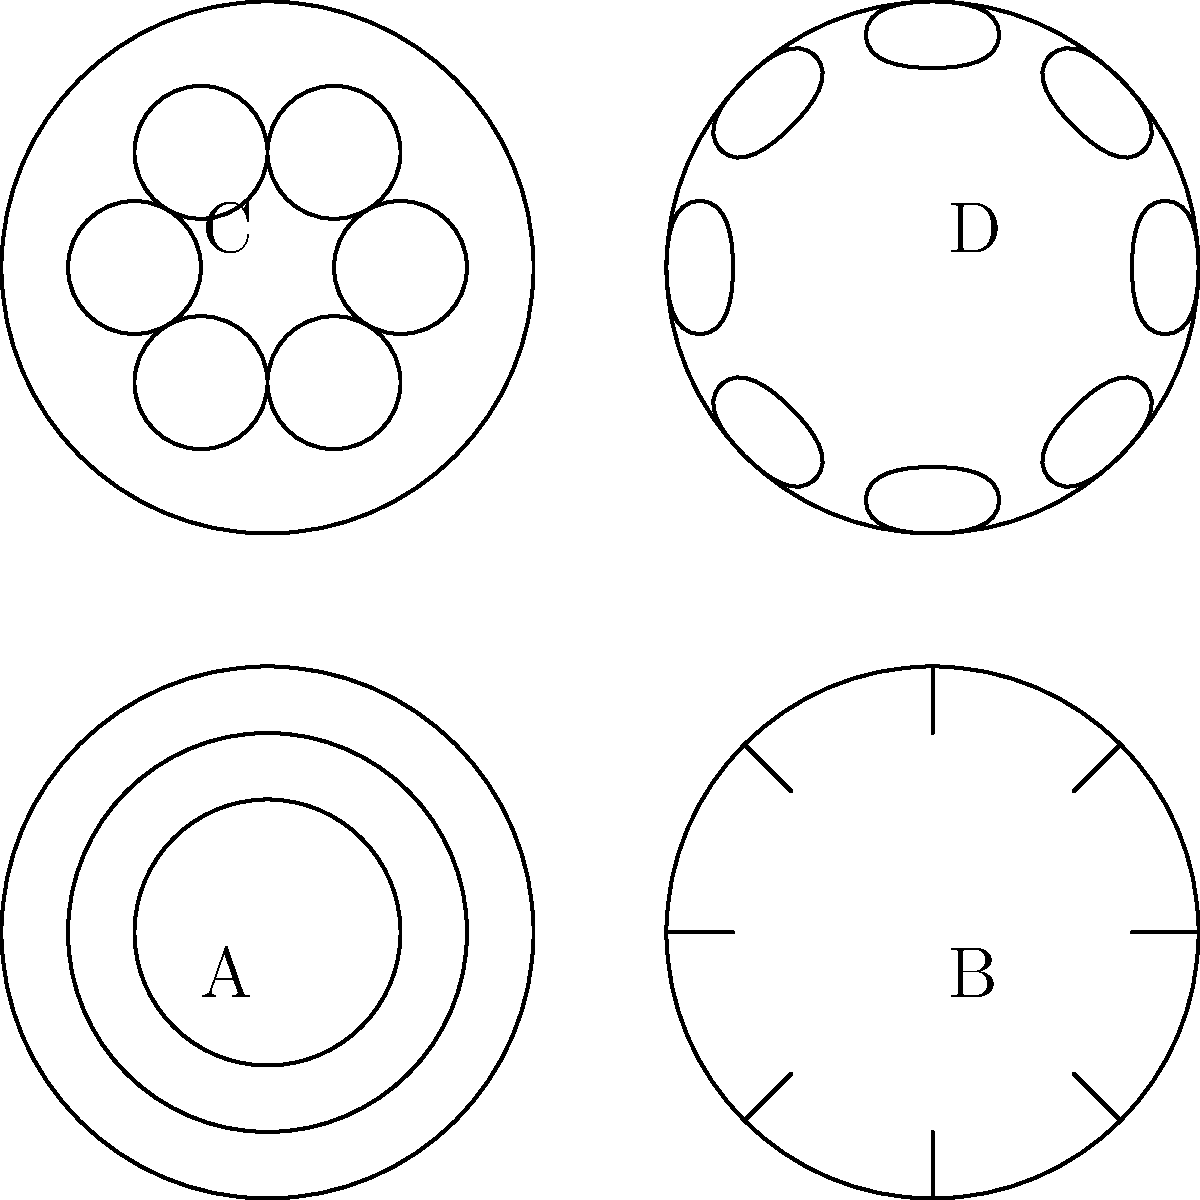The image shows four pottery designs (A, B, C, and D) from different periods of Islamic history. Based on your knowledge of Islamic art and pottery, arrange these designs in chronological order from the earliest to the latest period. To answer this question, we need to analyze each design and relate it to specific periods in Islamic art history:

1. Design A: This design features simple concentric circles. This basic geometric pattern is characteristic of early Islamic pottery, particularly from the Umayyad period (661-750 CE). The simplicity and focus on circular motifs reflect the early stages of Islamic decorative arts.

2. Design B: This pattern shows straight lines radiating from the center, creating a star-like pattern. This geometric style became more prominent during the Abbasid period (750-1258 CE), where more complex geometric patterns started to emerge.

3. Design C: This design incorporates small circular motifs arranged in a hexagonal pattern. This style is reminiscent of the middle Islamic period, particularly the Seljuk era (1037-1194 CE), where more intricate patterns and the use of repetitive motifs became common.

4. Design D: The floral or arabesque pattern in this design is characteristic of later Islamic art, particularly from the Ottoman period (1299-1922 CE). The naturalistic, curvilinear forms represent a more developed and refined style of Islamic decorative arts.

Therefore, the chronological order from earliest to latest would be:

A (Umayyad) → B (Abbasid) → C (Seljuk) → D (Ottoman)

This progression reflects the general evolution of Islamic pottery designs from simple geometric patterns to more complex and naturalistic forms over the centuries.
Answer: A, B, C, D 